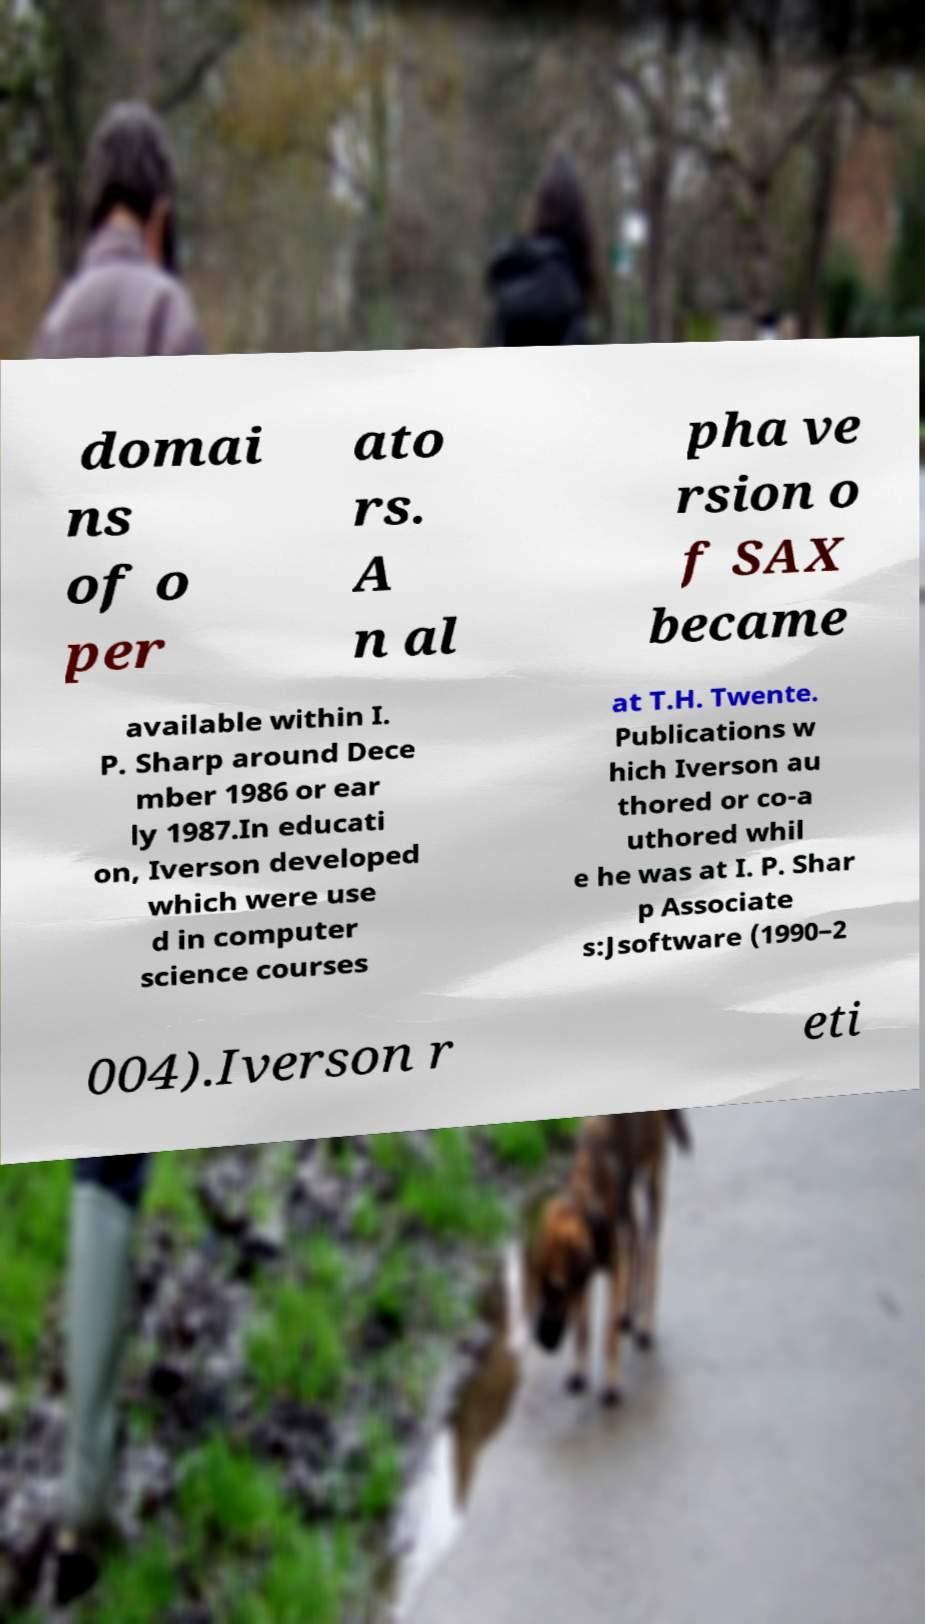Could you extract and type out the text from this image? domai ns of o per ato rs. A n al pha ve rsion o f SAX became available within I. P. Sharp around Dece mber 1986 or ear ly 1987.In educati on, Iverson developed which were use d in computer science courses at T.H. Twente. Publications w hich Iverson au thored or co-a uthored whil e he was at I. P. Shar p Associate s:Jsoftware (1990–2 004).Iverson r eti 